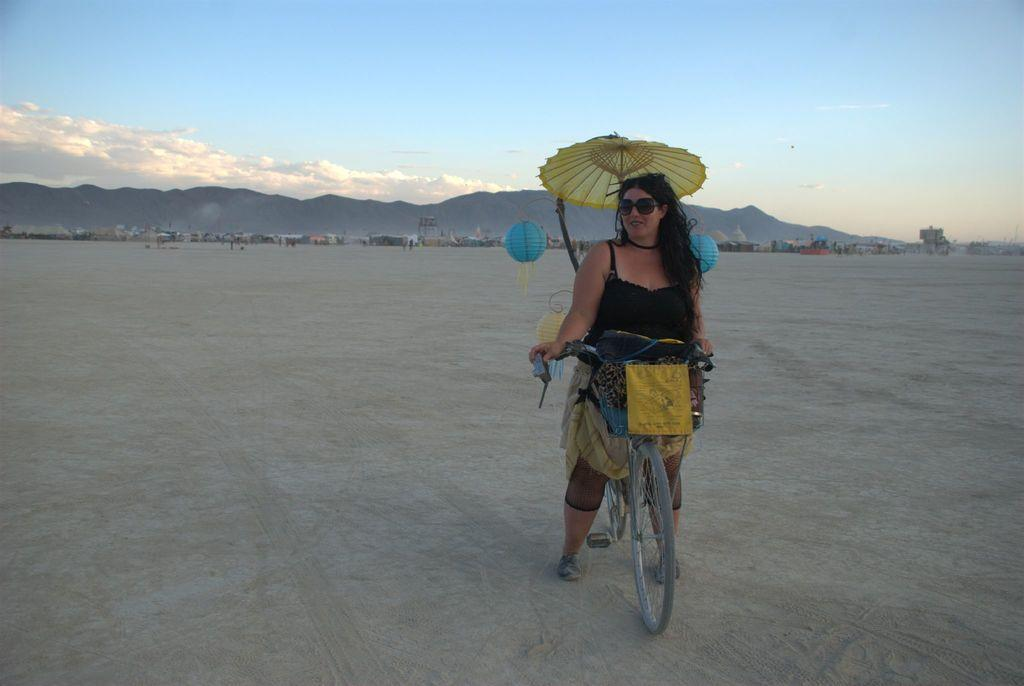What is the woman doing in the image? The woman is on a bicycle in the image. What object can be seen besides the woman and her bicycle? There is an umbrella in the image. What can be seen in the background of the image? There is a sky with clouds and a mountain in the background of the image. What type of baseball equipment can be seen in the image? There is no baseball equipment present in the image. What type of seat is attached to the bicycle in the image? The image does not show a seat attached to the bicycle; it only shows the woman on the bicycle. 